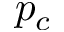Convert formula to latex. <formula><loc_0><loc_0><loc_500><loc_500>p _ { c }</formula> 